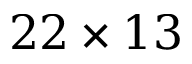Convert formula to latex. <formula><loc_0><loc_0><loc_500><loc_500>2 2 \times 1 3</formula> 